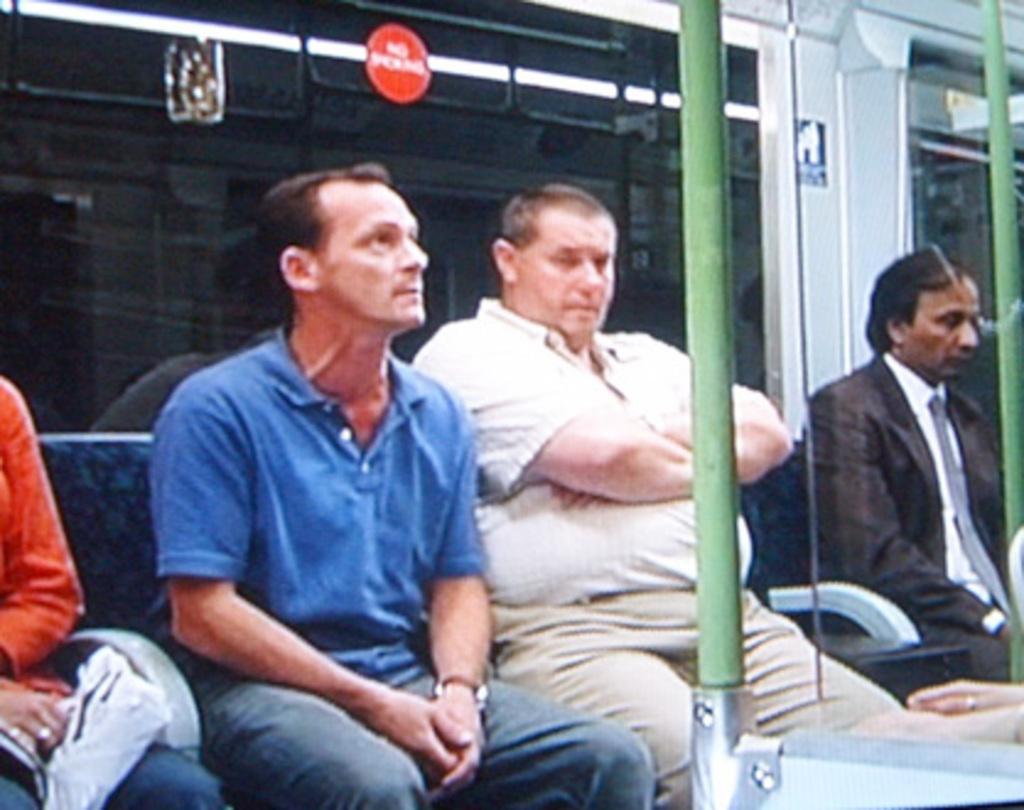How would you summarize this image in a sentence or two? As we can see in the image there are few people sitting on seats and there is a pole. 